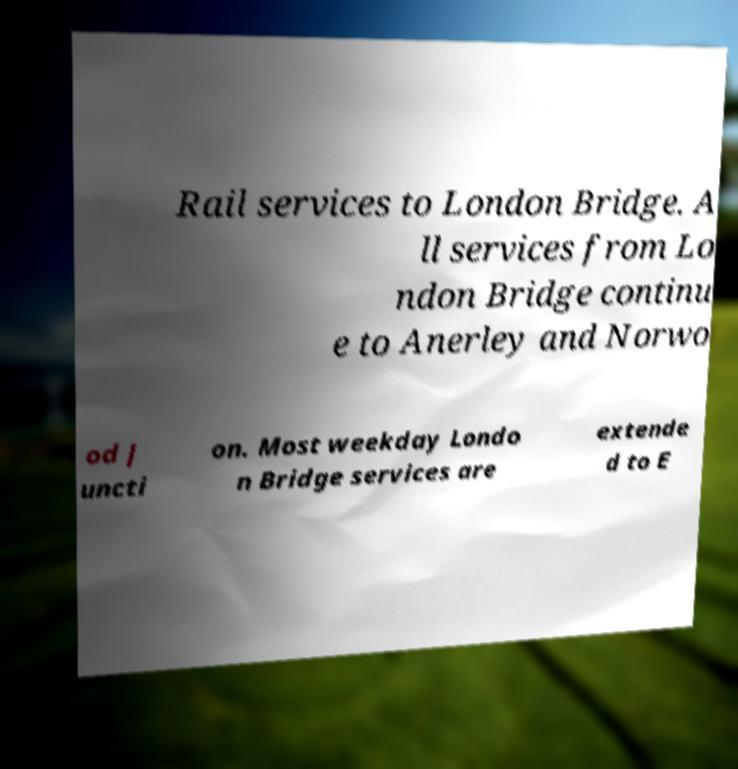Could you extract and type out the text from this image? Rail services to London Bridge. A ll services from Lo ndon Bridge continu e to Anerley and Norwo od J uncti on. Most weekday Londo n Bridge services are extende d to E 